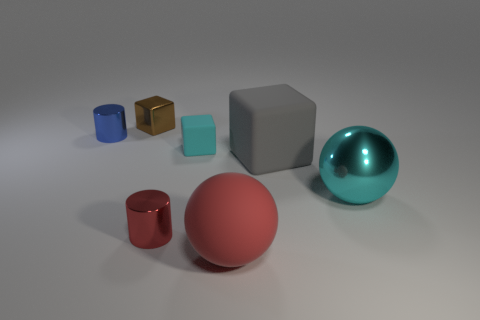Are there an equal number of tiny red metal cylinders that are behind the small blue shiny thing and large red matte cubes?
Your answer should be very brief. Yes. How many objects are either tiny objects that are behind the large gray matte cube or cyan matte cylinders?
Offer a terse response. 3. What shape is the shiny thing that is both on the left side of the rubber ball and to the right of the brown thing?
Your answer should be very brief. Cylinder. How many things are either big things that are in front of the gray rubber block or things that are behind the small red cylinder?
Offer a very short reply. 6. How many other things are the same size as the rubber ball?
Your response must be concise. 2. There is a ball that is behind the red shiny thing; is it the same color as the small matte thing?
Offer a very short reply. Yes. There is a thing that is both to the right of the tiny matte block and to the left of the big gray rubber thing; what size is it?
Make the answer very short. Large. What number of small objects are blue things or brown things?
Keep it short and to the point. 2. There is a large metallic thing that is on the right side of the large red matte object; what shape is it?
Your answer should be very brief. Sphere. What number of large cyan cylinders are there?
Offer a terse response. 0. 